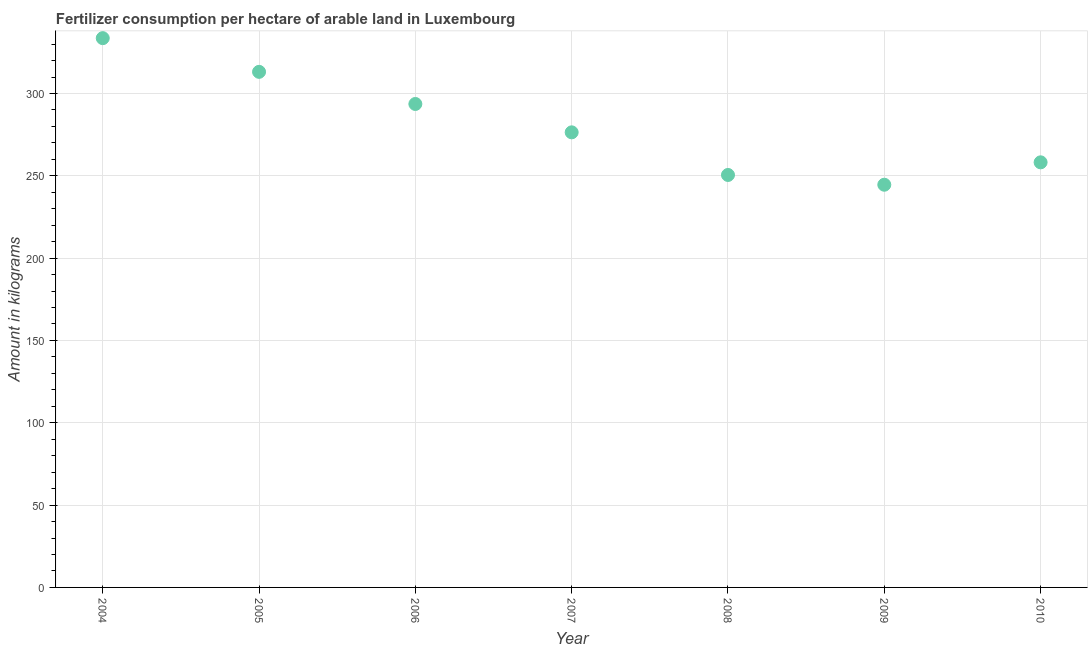What is the amount of fertilizer consumption in 2007?
Keep it short and to the point. 276.41. Across all years, what is the maximum amount of fertilizer consumption?
Your answer should be compact. 333.61. Across all years, what is the minimum amount of fertilizer consumption?
Provide a short and direct response. 244.58. In which year was the amount of fertilizer consumption maximum?
Provide a short and direct response. 2004. What is the sum of the amount of fertilizer consumption?
Make the answer very short. 1970.1. What is the difference between the amount of fertilizer consumption in 2006 and 2008?
Provide a short and direct response. 43.12. What is the average amount of fertilizer consumption per year?
Your response must be concise. 281.44. What is the median amount of fertilizer consumption?
Offer a terse response. 276.41. In how many years, is the amount of fertilizer consumption greater than 200 kg?
Give a very brief answer. 7. Do a majority of the years between 2009 and 2004 (inclusive) have amount of fertilizer consumption greater than 270 kg?
Make the answer very short. Yes. What is the ratio of the amount of fertilizer consumption in 2009 to that in 2010?
Make the answer very short. 0.95. Is the difference between the amount of fertilizer consumption in 2008 and 2009 greater than the difference between any two years?
Ensure brevity in your answer.  No. What is the difference between the highest and the second highest amount of fertilizer consumption?
Give a very brief answer. 20.46. Is the sum of the amount of fertilizer consumption in 2004 and 2005 greater than the maximum amount of fertilizer consumption across all years?
Your answer should be compact. Yes. What is the difference between the highest and the lowest amount of fertilizer consumption?
Your answer should be compact. 89.03. What is the difference between two consecutive major ticks on the Y-axis?
Keep it short and to the point. 50. Does the graph contain grids?
Your answer should be very brief. Yes. What is the title of the graph?
Offer a terse response. Fertilizer consumption per hectare of arable land in Luxembourg . What is the label or title of the X-axis?
Your answer should be compact. Year. What is the label or title of the Y-axis?
Offer a very short reply. Amount in kilograms. What is the Amount in kilograms in 2004?
Offer a very short reply. 333.61. What is the Amount in kilograms in 2005?
Provide a succinct answer. 313.15. What is the Amount in kilograms in 2006?
Provide a succinct answer. 293.63. What is the Amount in kilograms in 2007?
Offer a very short reply. 276.41. What is the Amount in kilograms in 2008?
Your answer should be compact. 250.52. What is the Amount in kilograms in 2009?
Offer a terse response. 244.58. What is the Amount in kilograms in 2010?
Ensure brevity in your answer.  258.19. What is the difference between the Amount in kilograms in 2004 and 2005?
Make the answer very short. 20.46. What is the difference between the Amount in kilograms in 2004 and 2006?
Ensure brevity in your answer.  39.98. What is the difference between the Amount in kilograms in 2004 and 2007?
Provide a succinct answer. 57.2. What is the difference between the Amount in kilograms in 2004 and 2008?
Offer a very short reply. 83.1. What is the difference between the Amount in kilograms in 2004 and 2009?
Keep it short and to the point. 89.03. What is the difference between the Amount in kilograms in 2004 and 2010?
Offer a terse response. 75.42. What is the difference between the Amount in kilograms in 2005 and 2006?
Provide a succinct answer. 19.52. What is the difference between the Amount in kilograms in 2005 and 2007?
Offer a terse response. 36.74. What is the difference between the Amount in kilograms in 2005 and 2008?
Keep it short and to the point. 62.63. What is the difference between the Amount in kilograms in 2005 and 2009?
Your answer should be very brief. 68.57. What is the difference between the Amount in kilograms in 2005 and 2010?
Make the answer very short. 54.96. What is the difference between the Amount in kilograms in 2006 and 2007?
Your answer should be compact. 17.22. What is the difference between the Amount in kilograms in 2006 and 2008?
Offer a terse response. 43.12. What is the difference between the Amount in kilograms in 2006 and 2009?
Keep it short and to the point. 49.05. What is the difference between the Amount in kilograms in 2006 and 2010?
Keep it short and to the point. 35.44. What is the difference between the Amount in kilograms in 2007 and 2008?
Provide a short and direct response. 25.89. What is the difference between the Amount in kilograms in 2007 and 2009?
Make the answer very short. 31.83. What is the difference between the Amount in kilograms in 2007 and 2010?
Give a very brief answer. 18.22. What is the difference between the Amount in kilograms in 2008 and 2009?
Your response must be concise. 5.93. What is the difference between the Amount in kilograms in 2008 and 2010?
Offer a very short reply. -7.68. What is the difference between the Amount in kilograms in 2009 and 2010?
Provide a short and direct response. -13.61. What is the ratio of the Amount in kilograms in 2004 to that in 2005?
Make the answer very short. 1.06. What is the ratio of the Amount in kilograms in 2004 to that in 2006?
Your response must be concise. 1.14. What is the ratio of the Amount in kilograms in 2004 to that in 2007?
Ensure brevity in your answer.  1.21. What is the ratio of the Amount in kilograms in 2004 to that in 2008?
Keep it short and to the point. 1.33. What is the ratio of the Amount in kilograms in 2004 to that in 2009?
Make the answer very short. 1.36. What is the ratio of the Amount in kilograms in 2004 to that in 2010?
Your answer should be very brief. 1.29. What is the ratio of the Amount in kilograms in 2005 to that in 2006?
Provide a short and direct response. 1.07. What is the ratio of the Amount in kilograms in 2005 to that in 2007?
Offer a terse response. 1.13. What is the ratio of the Amount in kilograms in 2005 to that in 2009?
Make the answer very short. 1.28. What is the ratio of the Amount in kilograms in 2005 to that in 2010?
Offer a very short reply. 1.21. What is the ratio of the Amount in kilograms in 2006 to that in 2007?
Ensure brevity in your answer.  1.06. What is the ratio of the Amount in kilograms in 2006 to that in 2008?
Provide a short and direct response. 1.17. What is the ratio of the Amount in kilograms in 2006 to that in 2009?
Ensure brevity in your answer.  1.2. What is the ratio of the Amount in kilograms in 2006 to that in 2010?
Offer a very short reply. 1.14. What is the ratio of the Amount in kilograms in 2007 to that in 2008?
Ensure brevity in your answer.  1.1. What is the ratio of the Amount in kilograms in 2007 to that in 2009?
Keep it short and to the point. 1.13. What is the ratio of the Amount in kilograms in 2007 to that in 2010?
Ensure brevity in your answer.  1.07. What is the ratio of the Amount in kilograms in 2008 to that in 2009?
Keep it short and to the point. 1.02. What is the ratio of the Amount in kilograms in 2009 to that in 2010?
Your response must be concise. 0.95. 